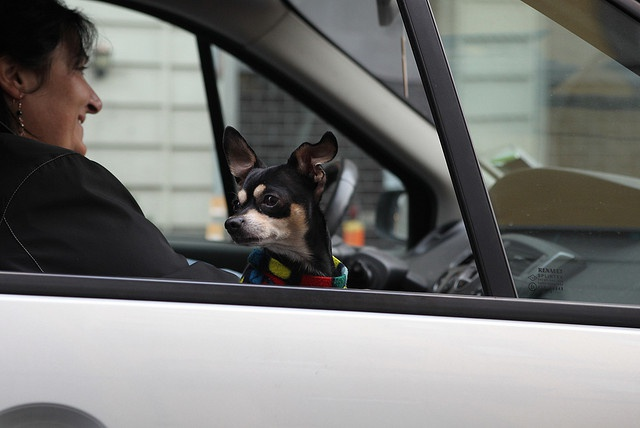Describe the objects in this image and their specific colors. I can see car in black, lightgray, darkgray, and gray tones, people in black, maroon, and gray tones, and dog in black, gray, maroon, and darkgreen tones in this image. 